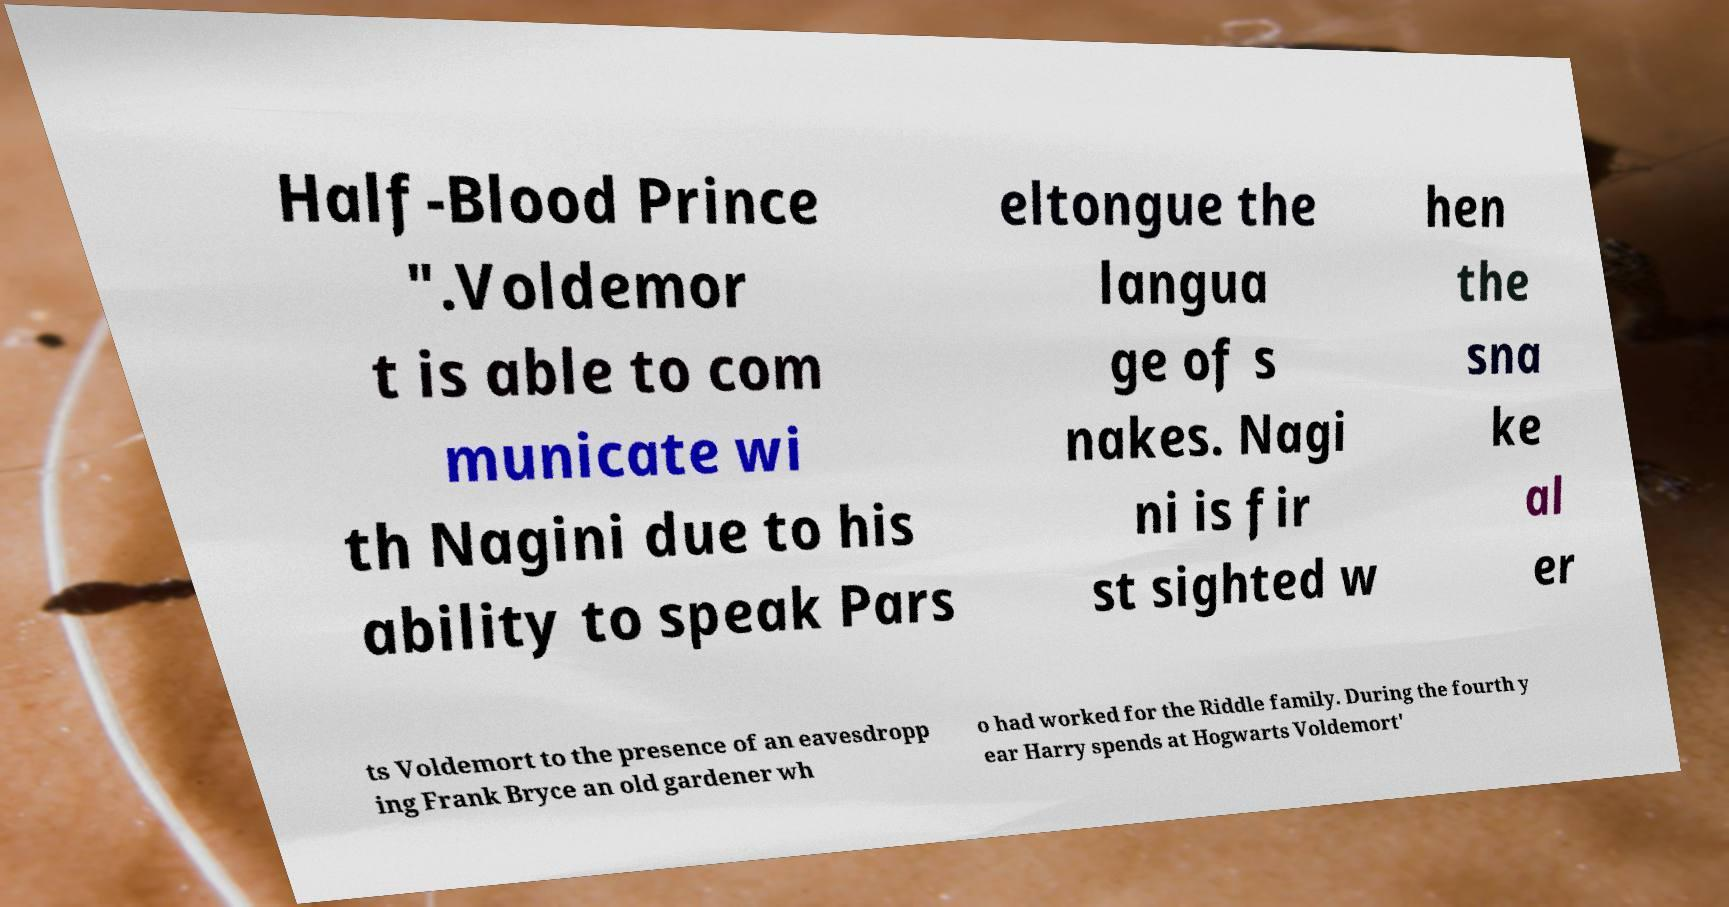Can you read and provide the text displayed in the image?This photo seems to have some interesting text. Can you extract and type it out for me? Half-Blood Prince ".Voldemor t is able to com municate wi th Nagini due to his ability to speak Pars eltongue the langua ge of s nakes. Nagi ni is fir st sighted w hen the sna ke al er ts Voldemort to the presence of an eavesdropp ing Frank Bryce an old gardener wh o had worked for the Riddle family. During the fourth y ear Harry spends at Hogwarts Voldemort' 